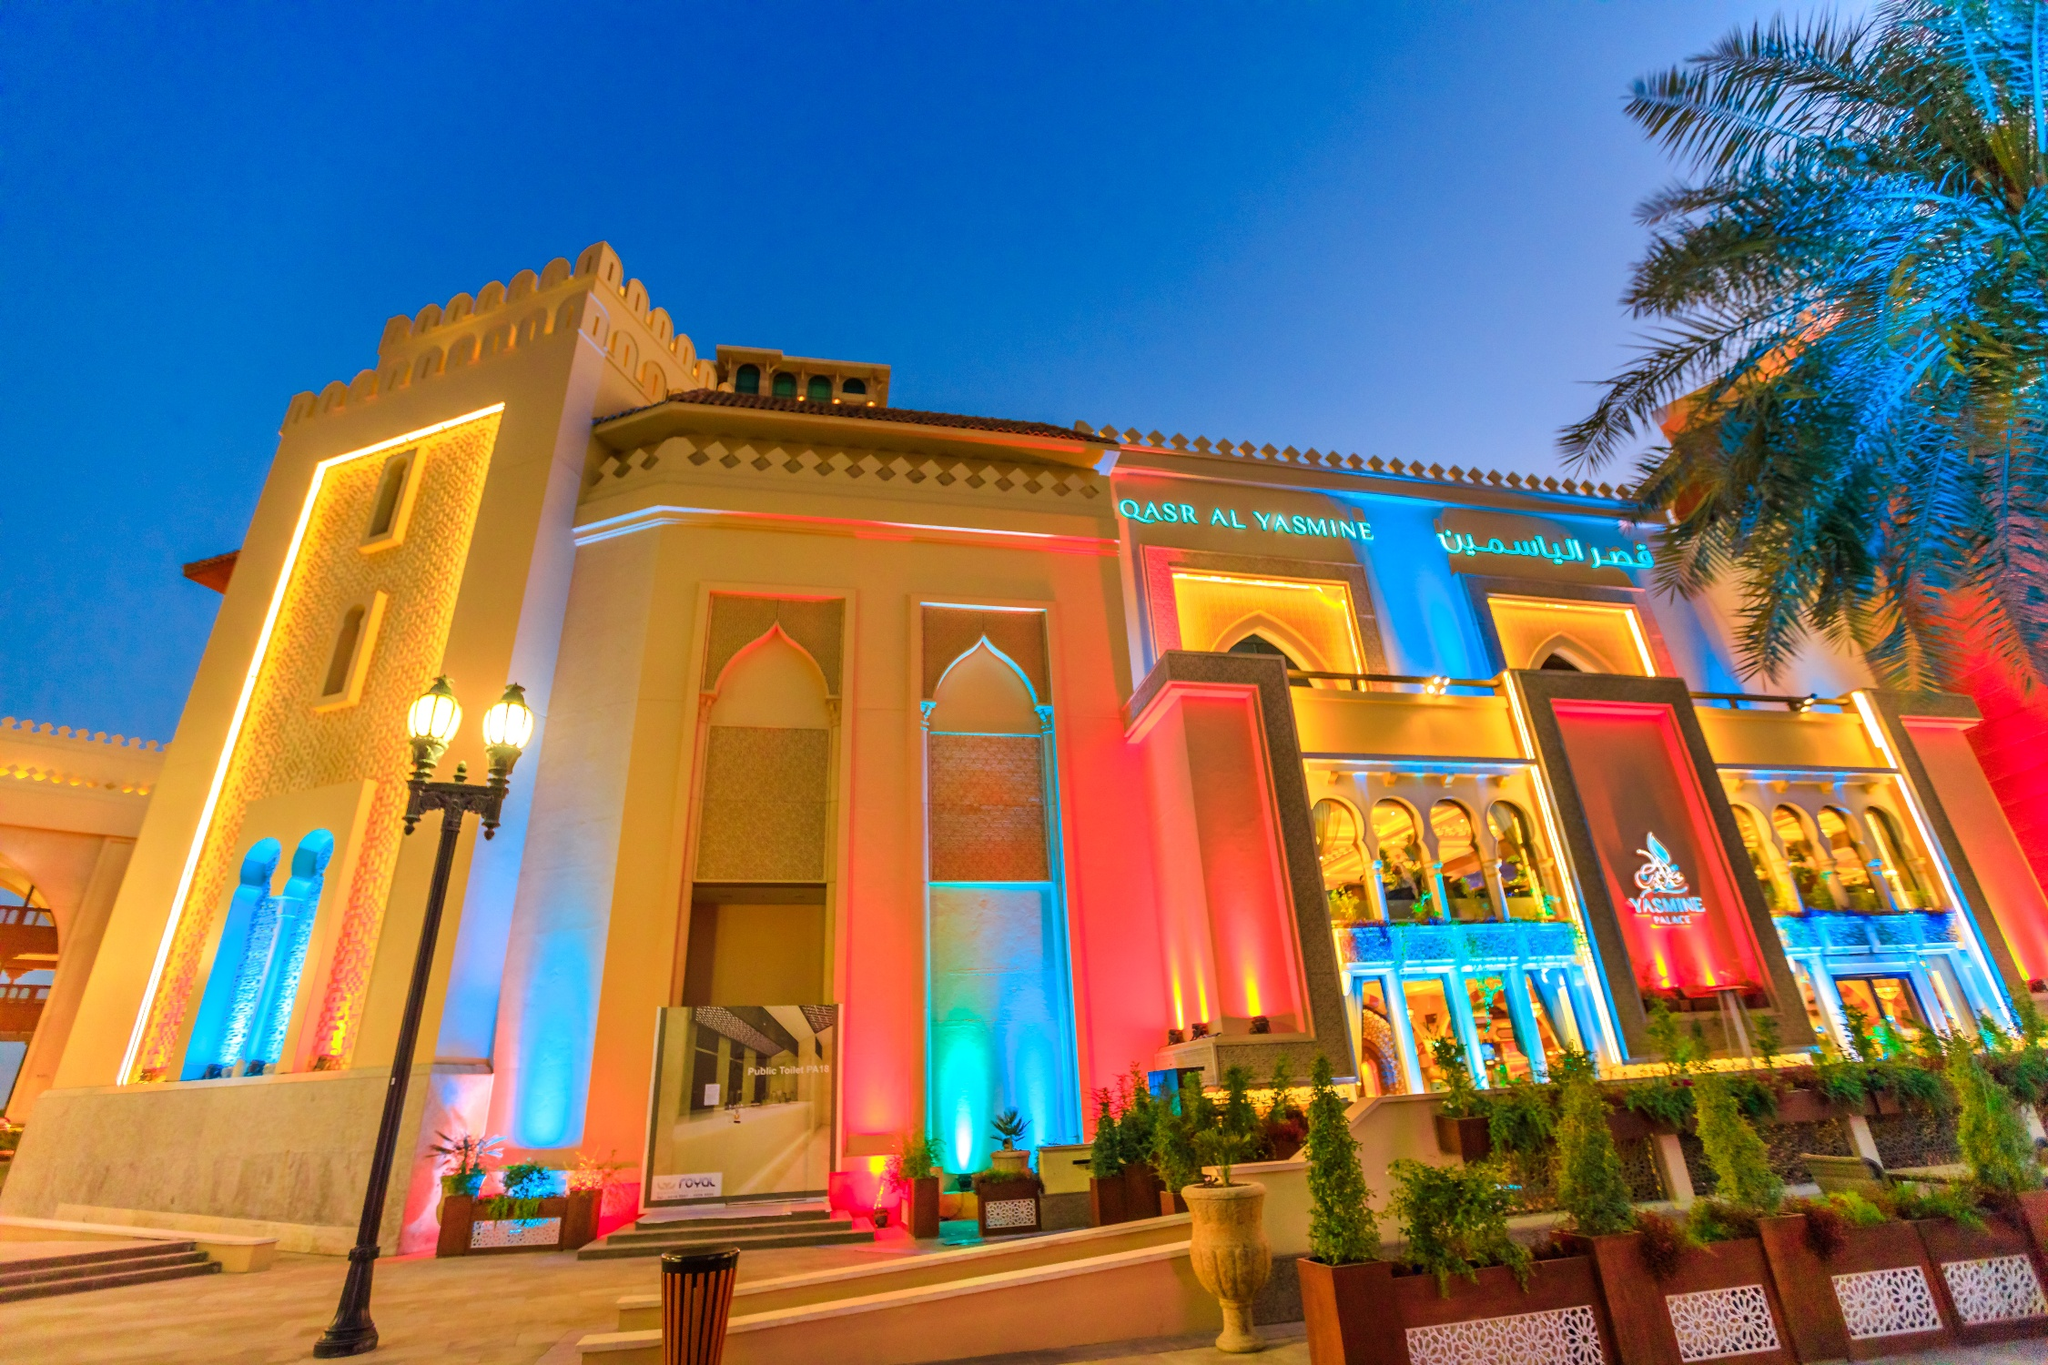Why is the use of lighting significant in showcasing Qasr Al Watan? The intricate lighting design is pivotal not just for aesthetic enhancement but also for symbolizing unity and diversity. Each hue employed casts the palace's architectural details in a new light, metaphorically reflecting the UAE's rich blend of traditions and modern advancements. The lighting serves as a visual narrative that celebrates the country's vibrant cultural tapestry and innovative spirit. 